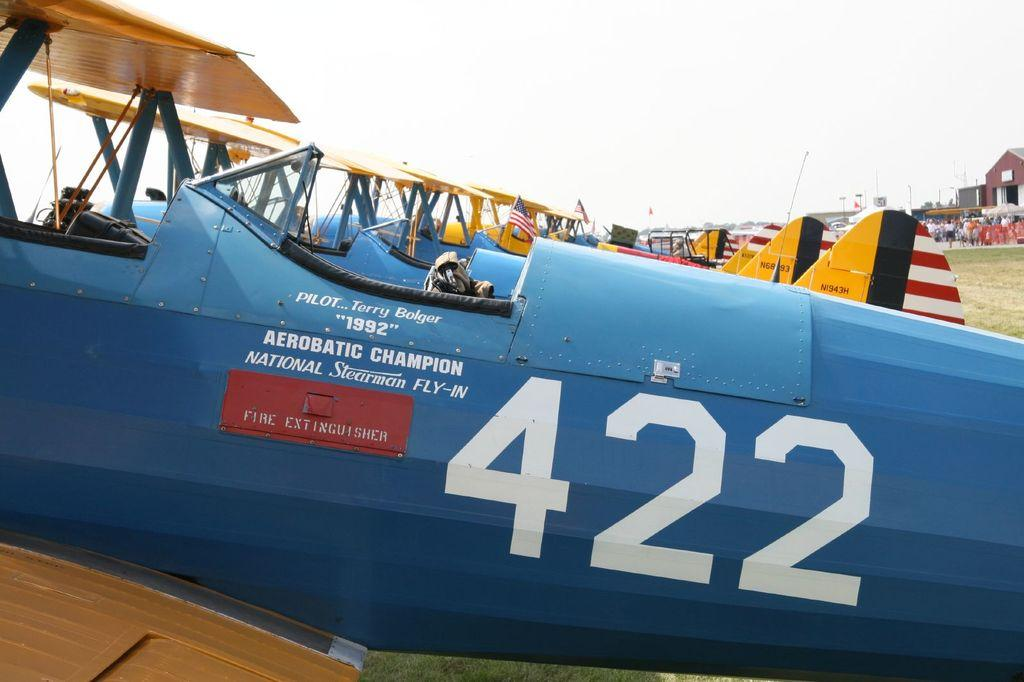<image>
Describe the image concisely. An airplane showing the numbers 422 on the side 